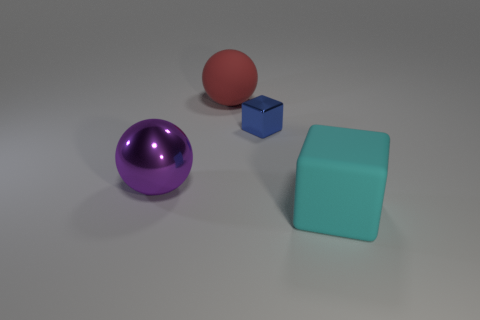The matte thing that is the same size as the cyan cube is what color? red 